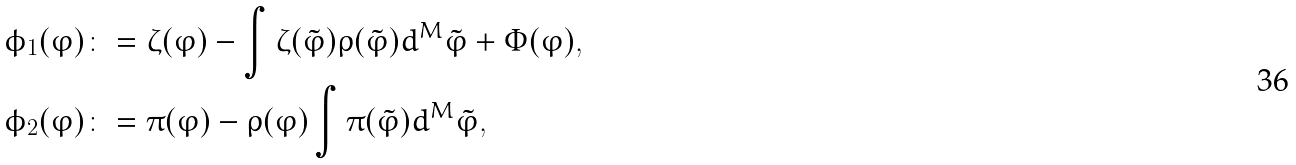Convert formula to latex. <formula><loc_0><loc_0><loc_500><loc_500>\phi _ { 1 } ( \varphi ) & \colon = \zeta ( \varphi ) - \int { \zeta ( \tilde { \varphi } ) \rho ( \tilde { \varphi } ) d ^ { M } \tilde { \varphi } } + \Phi ( \varphi ) , \\ \phi _ { 2 } ( \varphi ) & \colon = \pi ( \varphi ) - \rho ( \varphi ) \int { \pi ( \tilde { \varphi } ) d ^ { M } \tilde { \varphi } } ,</formula> 